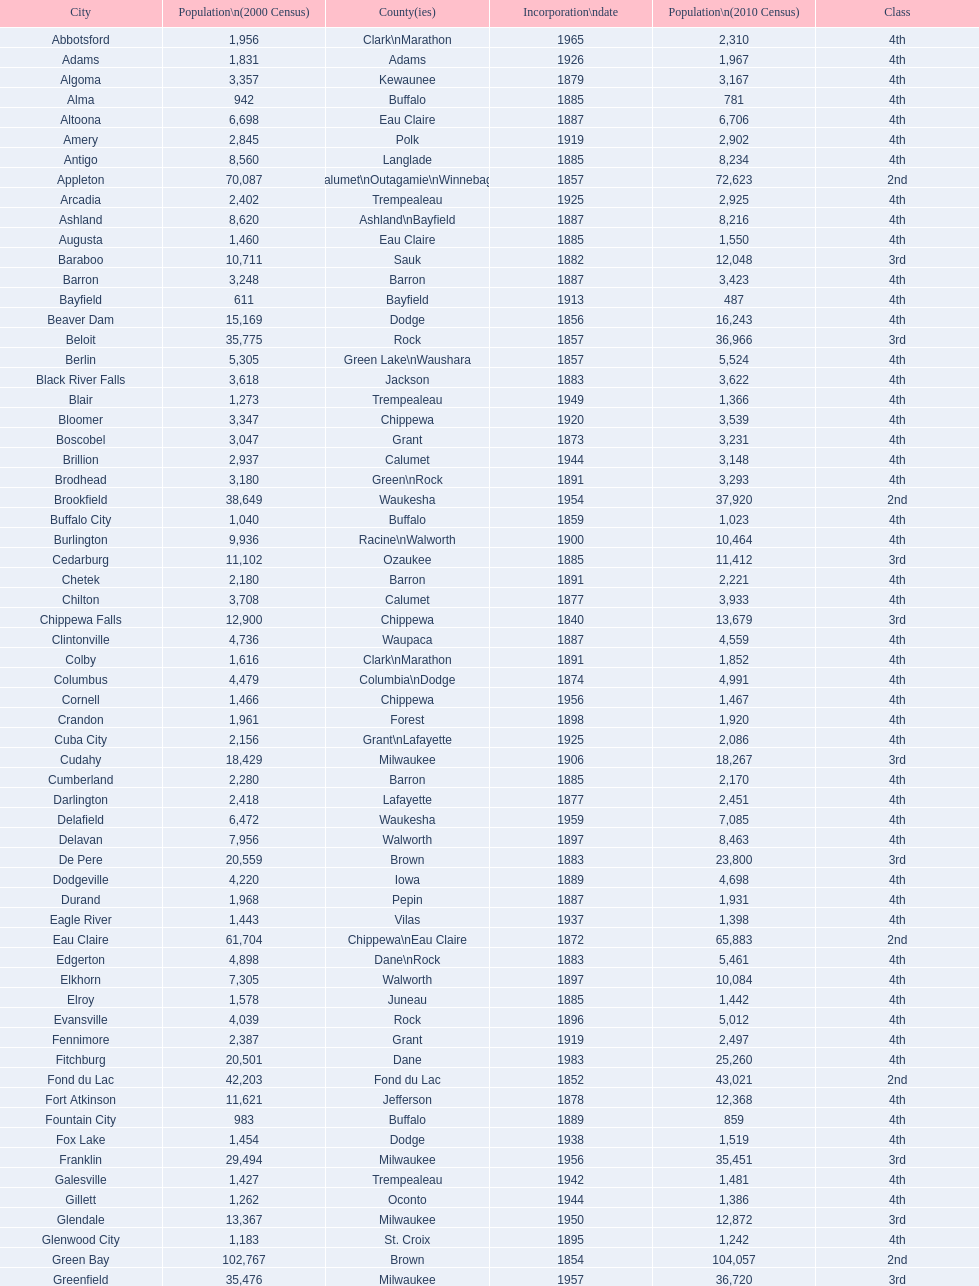How many cities have 1926 as their incorporation date? 2. 